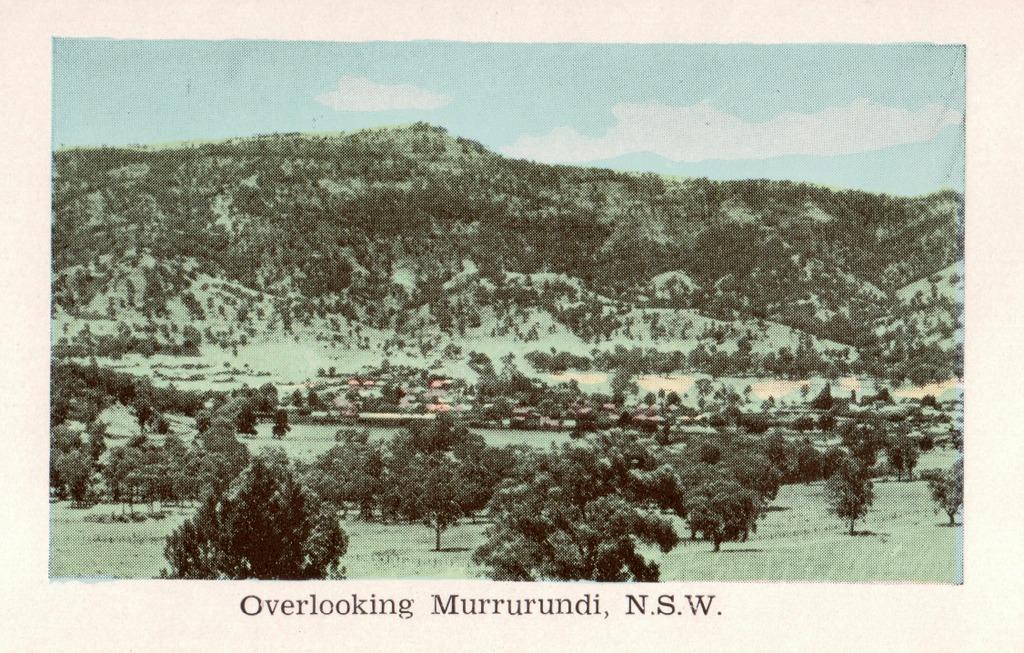Could you give a brief overview of what you see in this image? This is an edited image in which there are trees and there are plants and there is some text written on the image and there is a mountain in the background. 